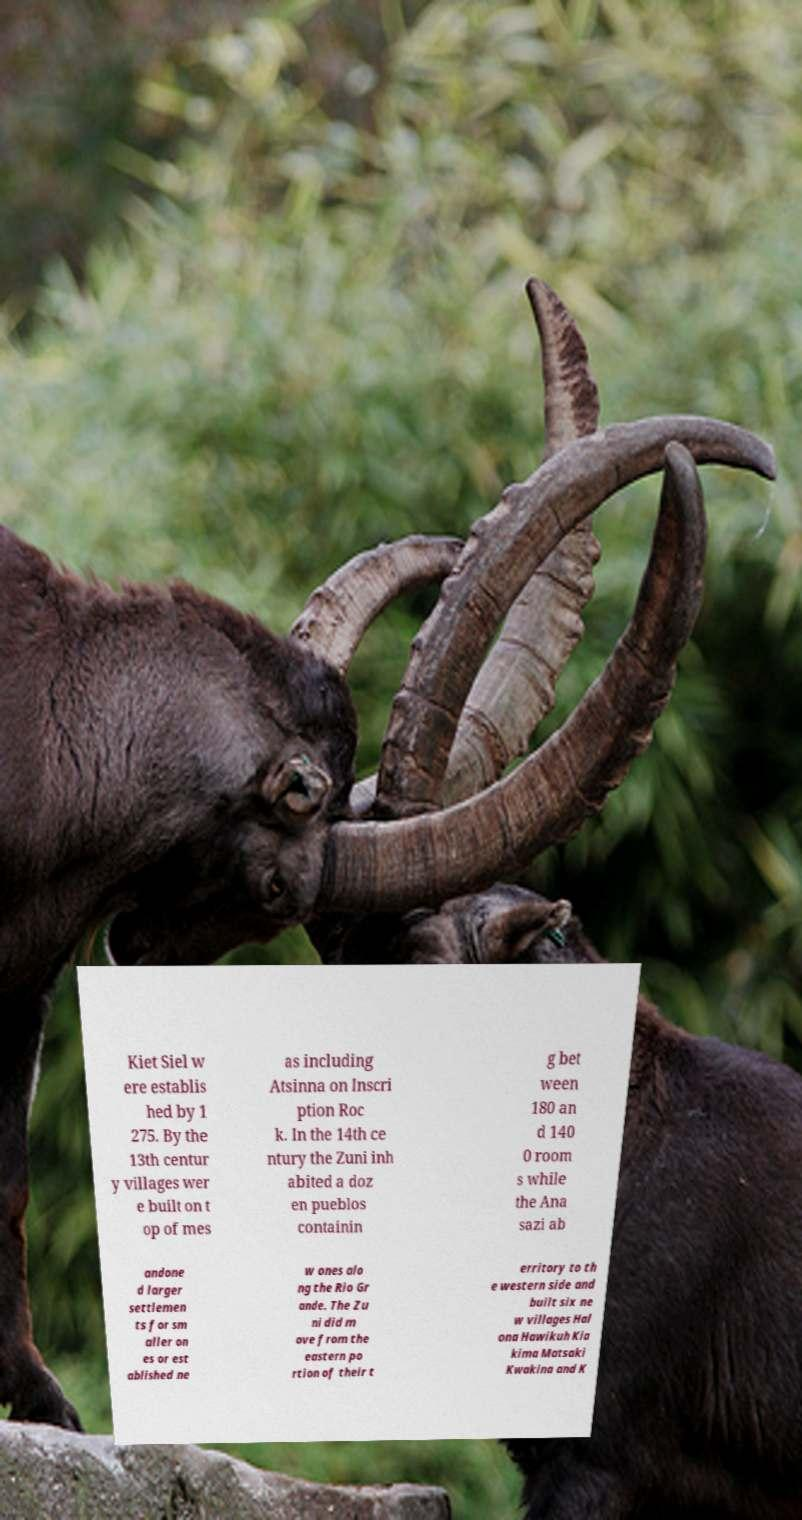Please read and relay the text visible in this image. What does it say? Kiet Siel w ere establis hed by 1 275. By the 13th centur y villages wer e built on t op of mes as including Atsinna on Inscri ption Roc k. In the 14th ce ntury the Zuni inh abited a doz en pueblos containin g bet ween 180 an d 140 0 room s while the Ana sazi ab andone d larger settlemen ts for sm aller on es or est ablished ne w ones alo ng the Rio Gr ande. The Zu ni did m ove from the eastern po rtion of their t erritory to th e western side and built six ne w villages Hal ona Hawikuh Kia kima Matsaki Kwakina and K 